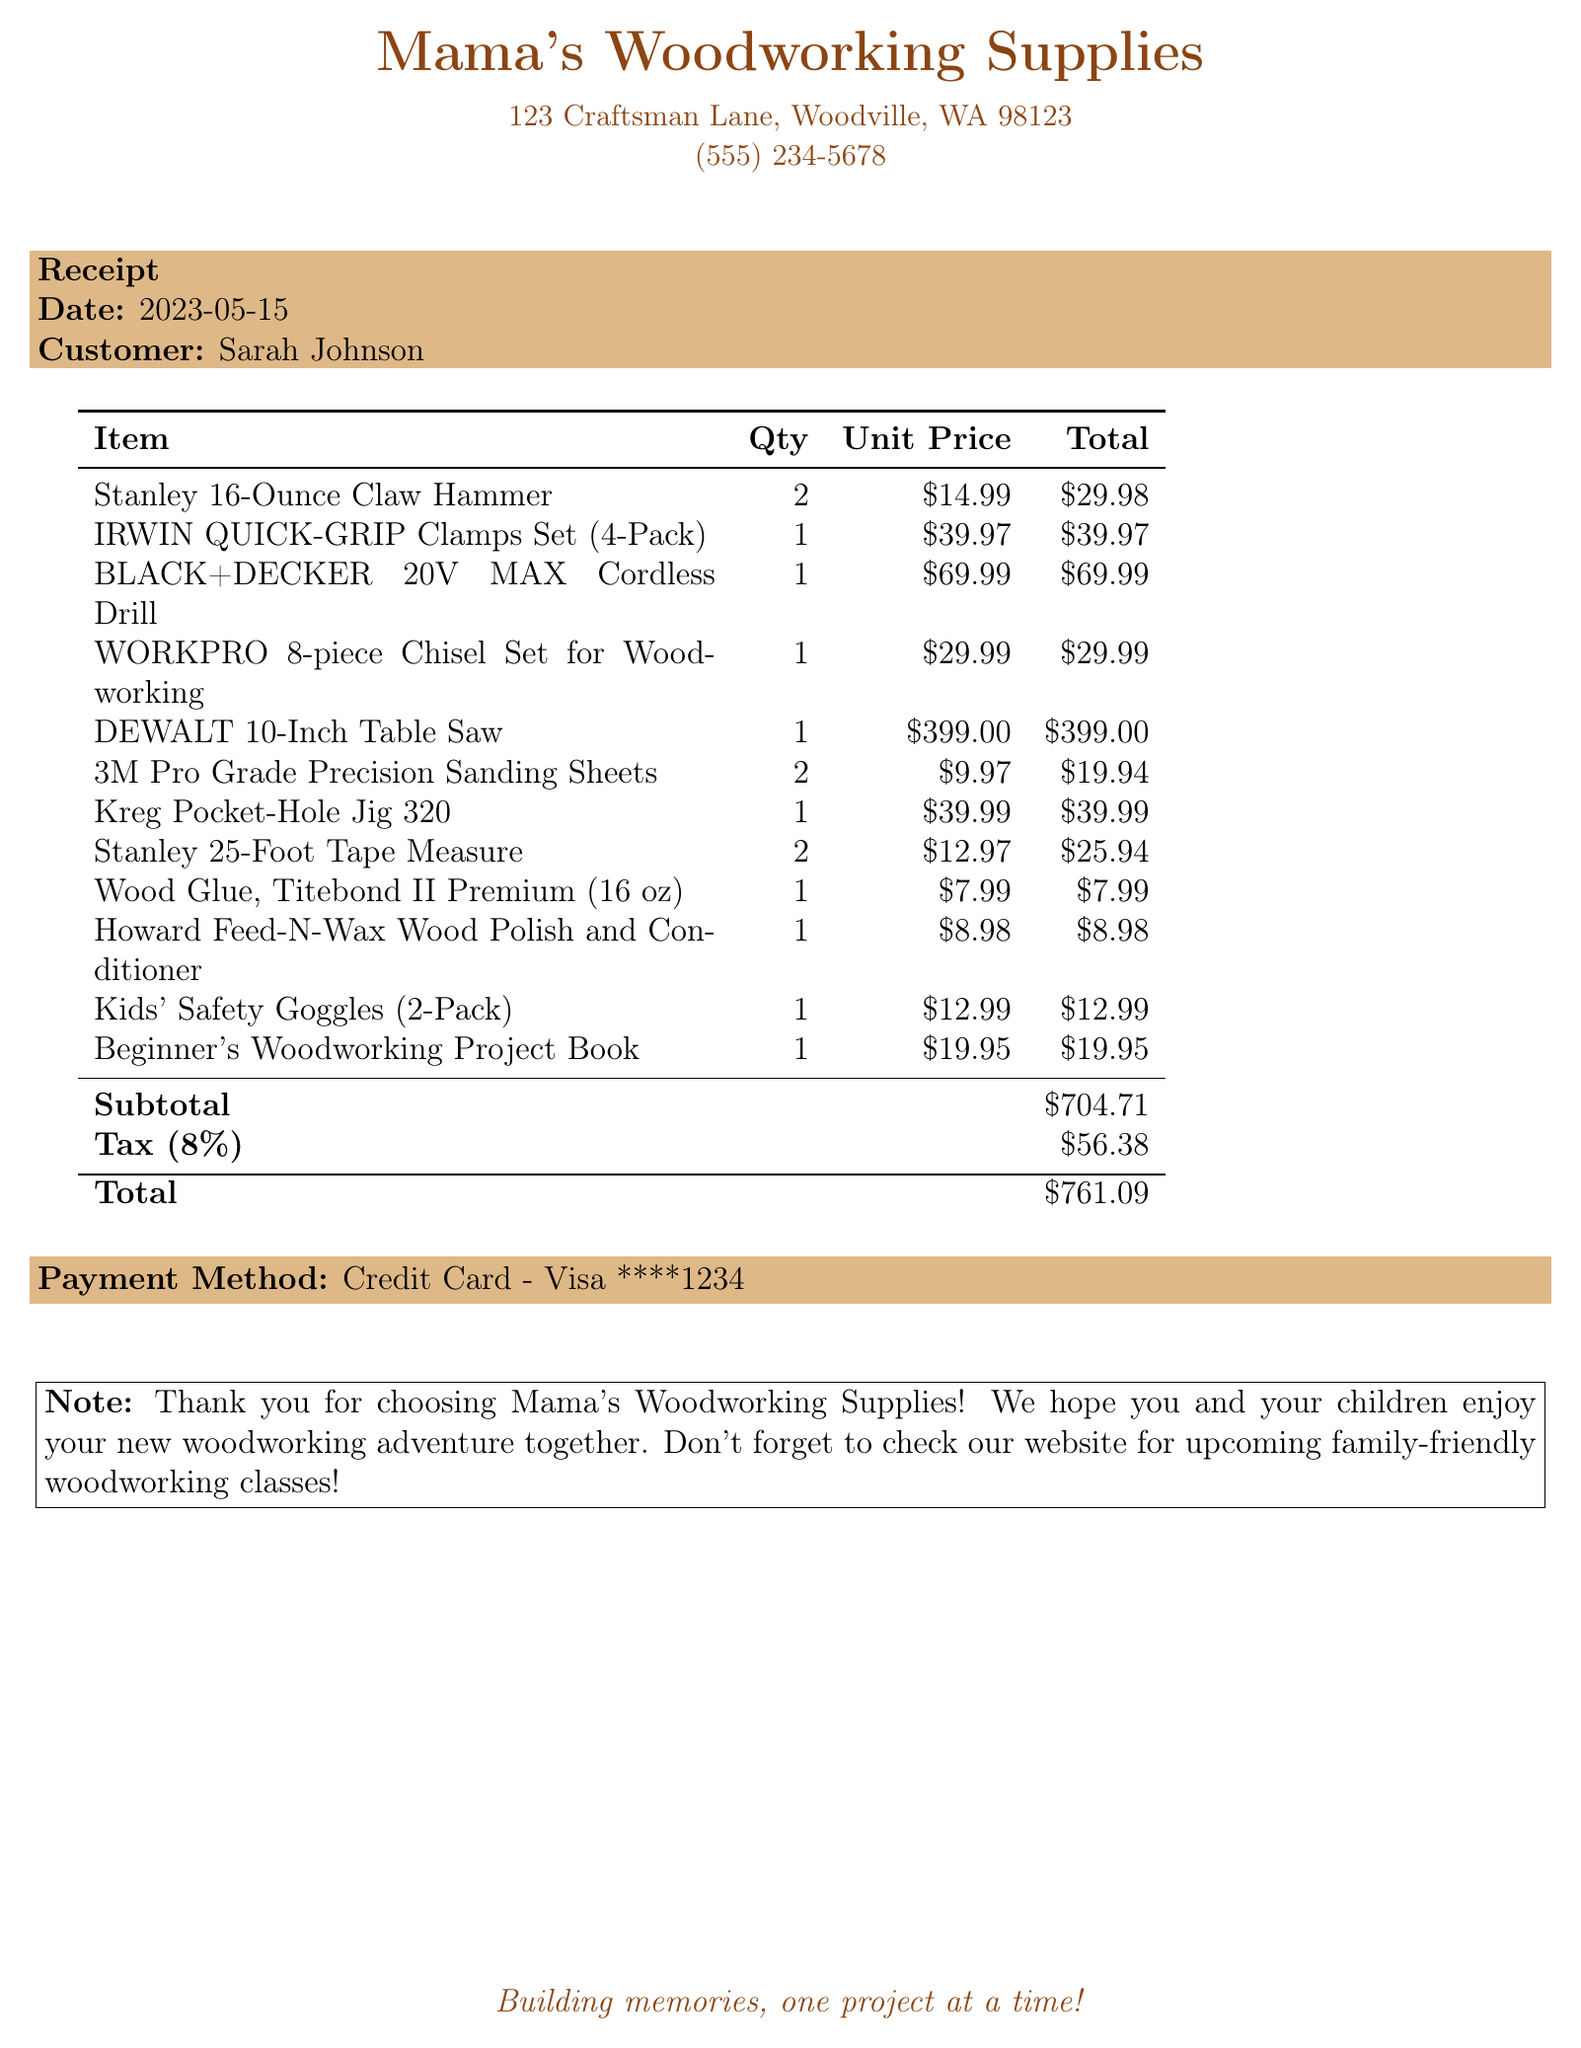What is the store name? The store name is given at the top of the receipt.
Answer: Mama's Woodworking Supplies What is the total amount of the purchase? The total amount is listed at the bottom of the receipt.
Answer: $761.09 How many Stanley 16-Ounce Claw Hammers were purchased? The quantity of Stanley 16-Ounce Claw Hammers is provided in the item list.
Answer: 2 What is the unit price of the BLACK+DECKER 20V MAX Cordless Drill? The unit price is specified alongside the item in the receipt.
Answer: $69.99 What is the tax rate applied to the purchase? The tax rate is stated directly on the receipt for customer information.
Answer: 8% What is included in the notes section? The notes section contains a message to the customer about their purchase.
Answer: Thank you for choosing Mama's Woodworking Supplies! We hope you and your children enjoy your new woodworking adventure together. Don't forget to check our website for upcoming family-friendly woodworking classes! What is the customer’s name? The customer's name is displayed prominently on the receipt.
Answer: Sarah Johnson What is the total number of items purchased? The total number of items reflects the sum of all quantities listed in the receipt.
Answer: 12 